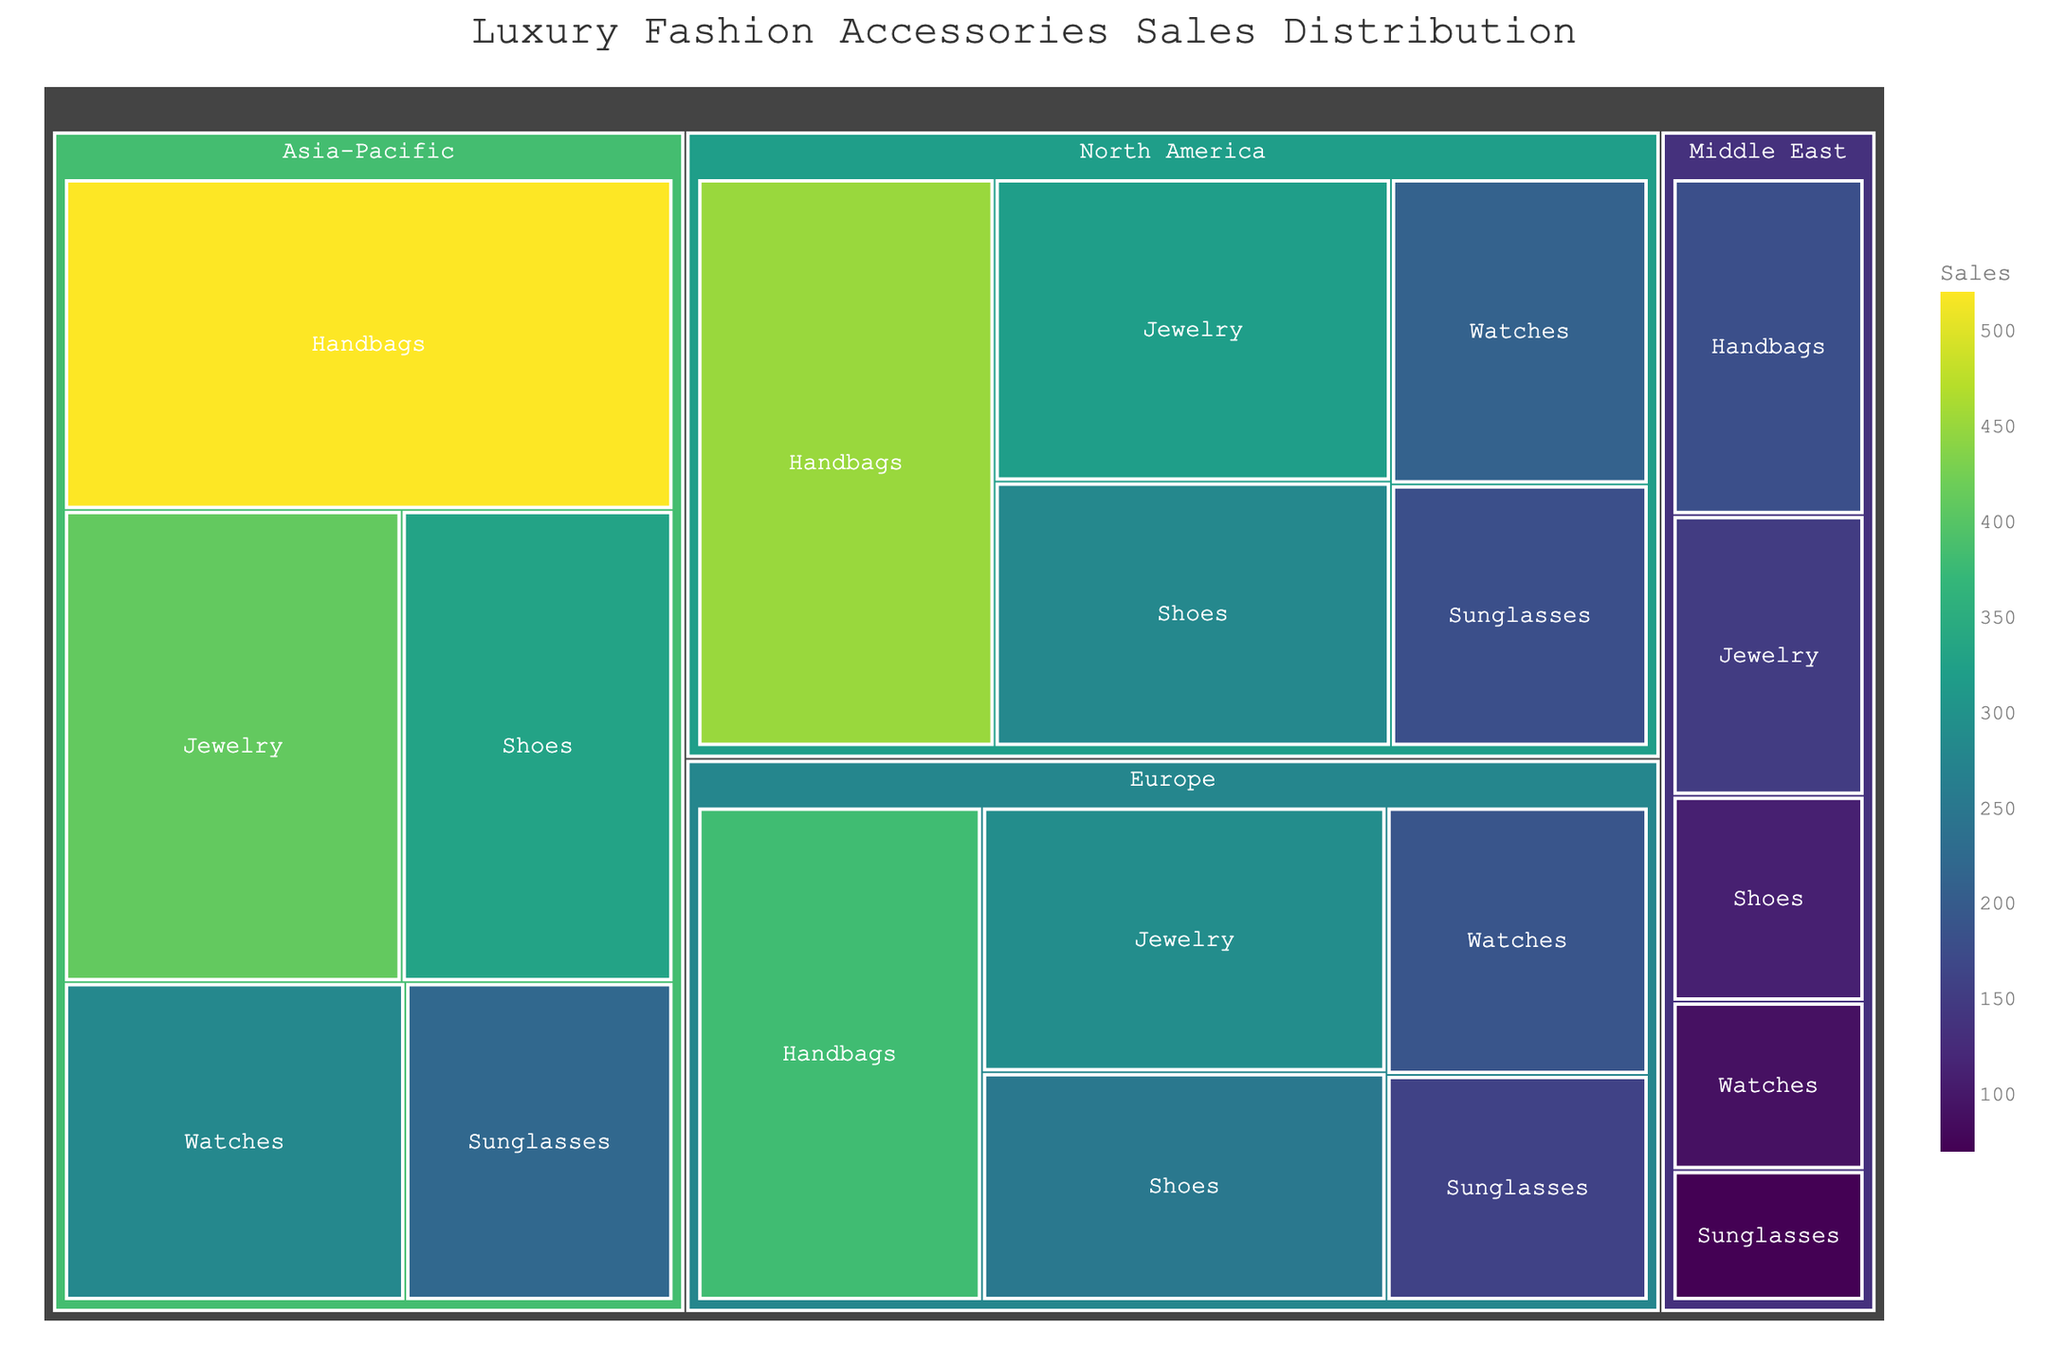What is the title of the treemap? The title is displayed at the center-top of the figure and usually summarizes the visualized data. Here, the title is positioned in a larger, prominent font.
Answer: Luxury Fashion Accessories Sales Distribution Which product category has the highest sales in the Asia-Pacific region? Focus on the Asia-Pacific section of the treemap. The largest rectangle in this region represents the product category with the highest sales.
Answer: Handbags Compare the sales of handbags between North America and Europe. Which region has higher sales? Locate the rectangles representing handbags in both North America and Europe. The sales can be determined by the size of these rectangles.
Answer: North America What is the combined sales value of watches in North America and Europe? Find the rectangles for watches in both North America and Europe. Sum the sales values shown.
Answer: 400 (210 + 190) Which region has the smallest total sales in the treemap? Evaluate the size of the regions as a whole. The region with the smallest total area represents the region with the smallest sales.
Answer: Middle East Compare the sales of jewelry in the Asia-Pacific and North America regions. Which is higher? Look at the rectangles representing jewelry in both regions. Compare their sizes or the sales values shown within each rectangle.
Answer: Asia-Pacific What is the range of sales for shoes across all regions? Identify the sales values for shoes in all regions: North America, Europe, Asia-Pacific, and Middle East. Calculate the difference between the highest and the lowest value.
Answer: 220 (330 - 110) How do the sales of sunglasses in Europe compare to those in the Middle East? Locate the rectangles for sunglasses in both Europe and Middle East. Compare their sizes or sales values.
Answer: Europe Which product category has the most balanced sales distribution across all regions? Look for the category where the rectangles across all regions are most similar in size. This indicates a balanced distribution of sales.
Answer: Jewelry What are the top three regions in terms of overall sales for all categories combined? Sum the sales values for all categories within each region. The regions with the highest totals are the top three.
Answer: Asia-Pacific, North America, Europe 